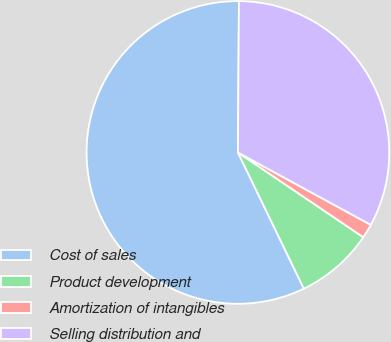Convert chart. <chart><loc_0><loc_0><loc_500><loc_500><pie_chart><fcel>Cost of sales<fcel>Product development<fcel>Amortization of intangibles<fcel>Selling distribution and<nl><fcel>57.29%<fcel>8.36%<fcel>1.52%<fcel>32.83%<nl></chart> 